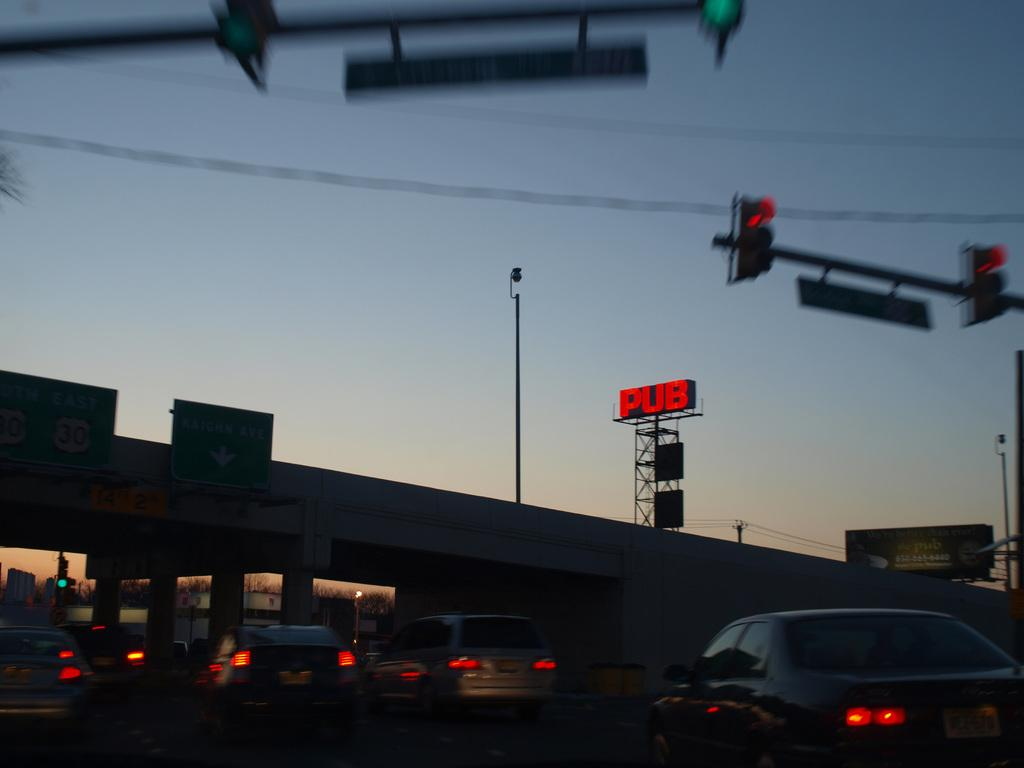<image>
Provide a brief description of the given image. A red sign for "PUB" is lit up in the distance beyond some traffic. 